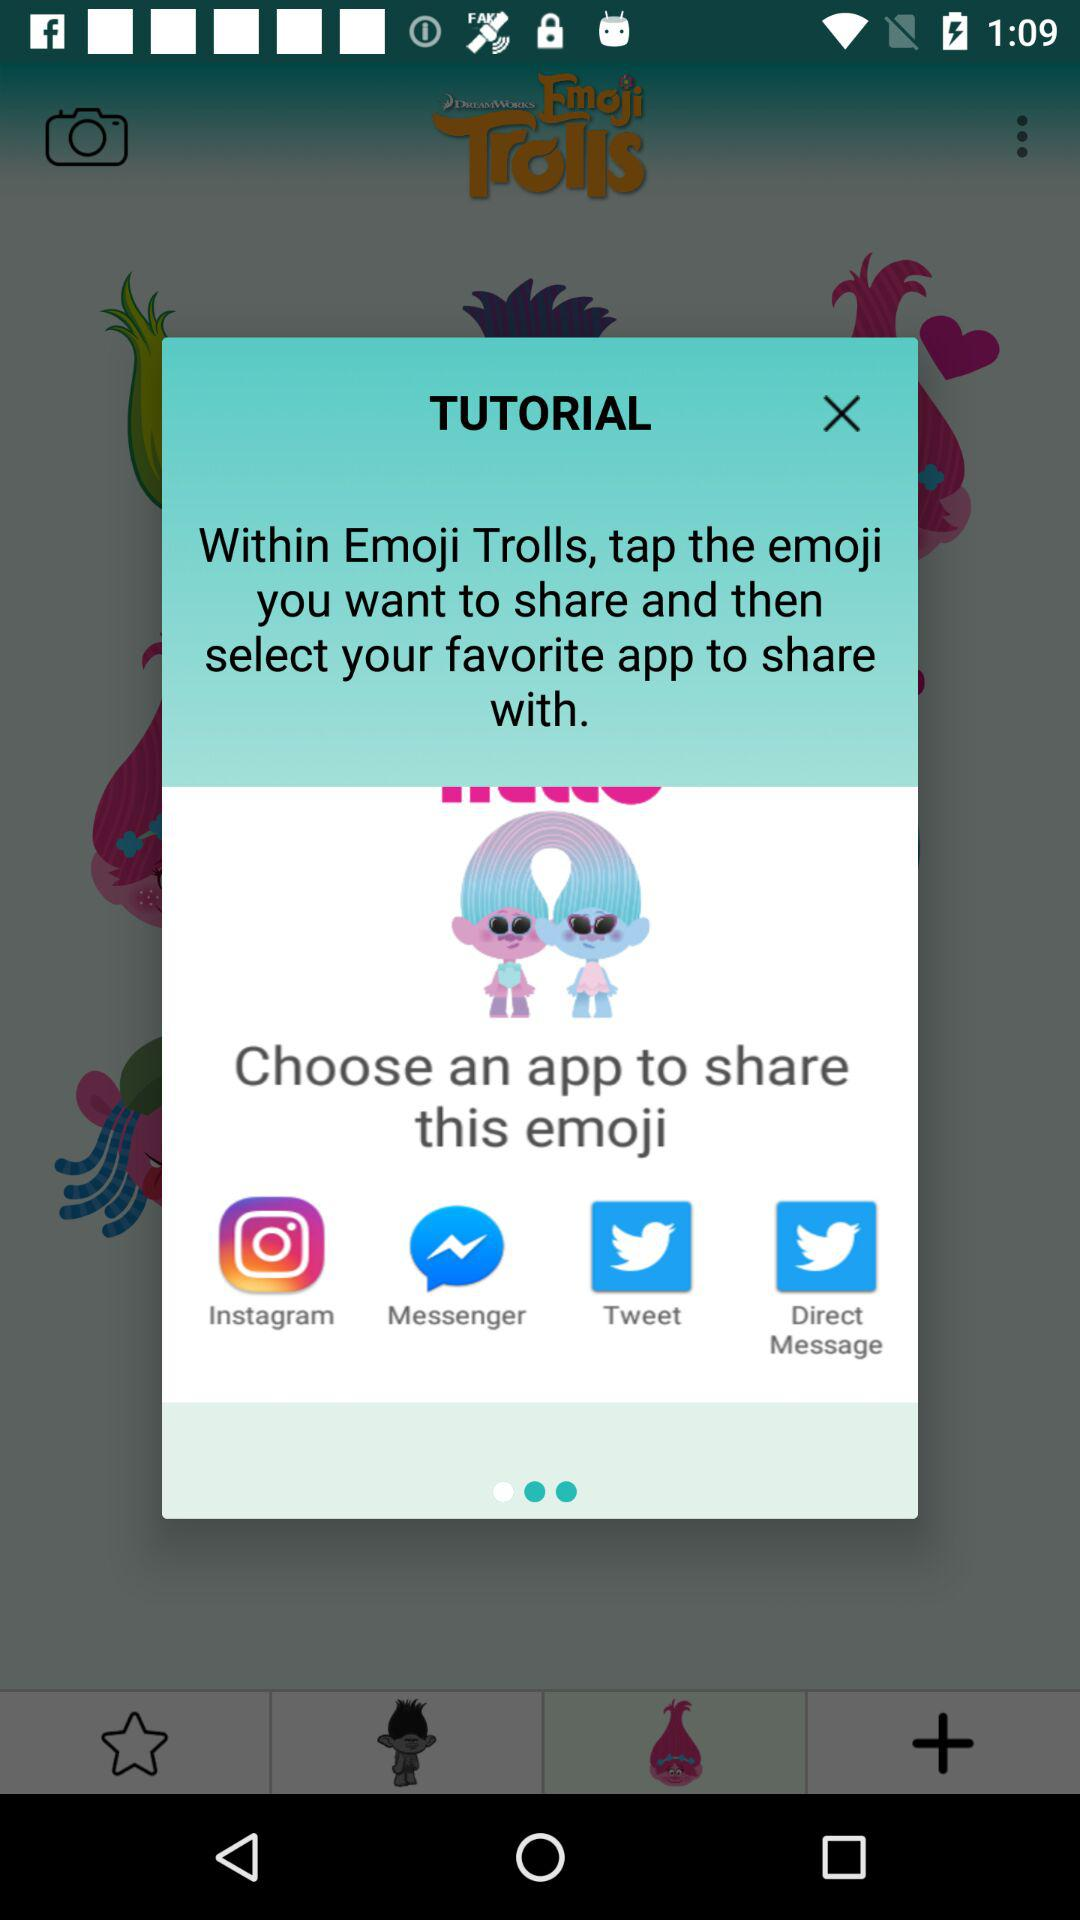Through which applications can the emoji be shared? The applications through which the emoji can be shared are "Instagram", "Messenger", "Tweet" and "Direct Message". 